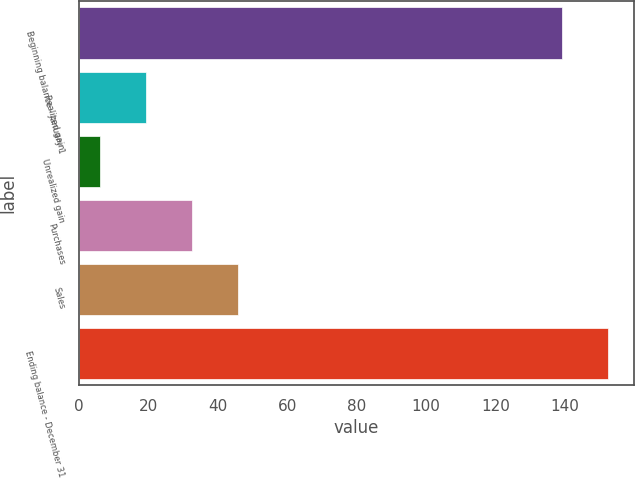<chart> <loc_0><loc_0><loc_500><loc_500><bar_chart><fcel>Beginning balance - January 1<fcel>Realized gain<fcel>Unrealized gain<fcel>Purchases<fcel>Sales<fcel>Ending balance - December 31<nl><fcel>139<fcel>19.3<fcel>6<fcel>32.6<fcel>45.9<fcel>152.3<nl></chart> 